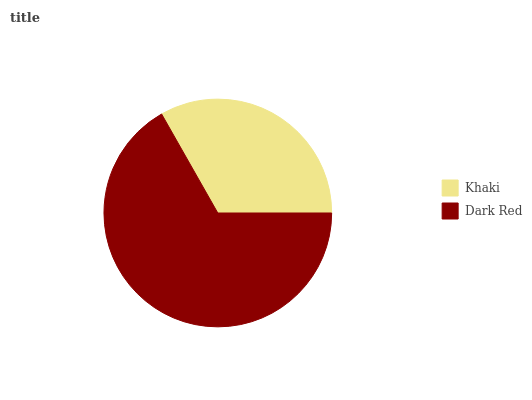Is Khaki the minimum?
Answer yes or no. Yes. Is Dark Red the maximum?
Answer yes or no. Yes. Is Dark Red the minimum?
Answer yes or no. No. Is Dark Red greater than Khaki?
Answer yes or no. Yes. Is Khaki less than Dark Red?
Answer yes or no. Yes. Is Khaki greater than Dark Red?
Answer yes or no. No. Is Dark Red less than Khaki?
Answer yes or no. No. Is Dark Red the high median?
Answer yes or no. Yes. Is Khaki the low median?
Answer yes or no. Yes. Is Khaki the high median?
Answer yes or no. No. Is Dark Red the low median?
Answer yes or no. No. 